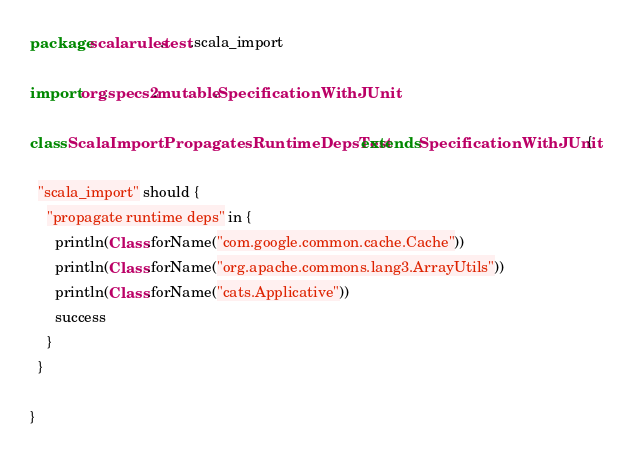Convert code to text. <code><loc_0><loc_0><loc_500><loc_500><_Scala_>package scalarules.test.scala_import

import org.specs2.mutable.SpecificationWithJUnit

class ScalaImportPropagatesRuntimeDepsTest extends SpecificationWithJUnit {

  "scala_import" should {
    "propagate runtime deps" in {
      println(Class.forName("com.google.common.cache.Cache"))
      println(Class.forName("org.apache.commons.lang3.ArrayUtils"))
      println(Class.forName("cats.Applicative"))
      success
    }
  }

}
</code> 